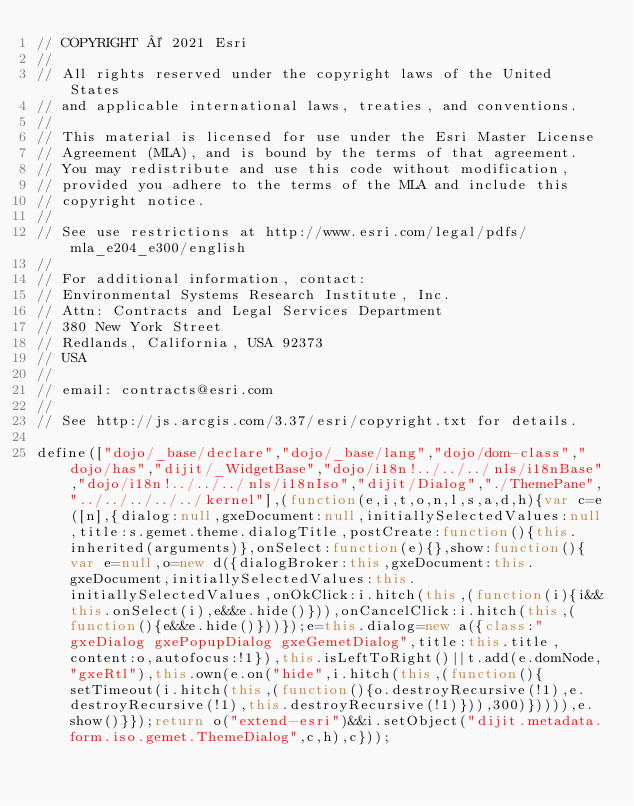<code> <loc_0><loc_0><loc_500><loc_500><_JavaScript_>// COPYRIGHT © 2021 Esri
//
// All rights reserved under the copyright laws of the United States
// and applicable international laws, treaties, and conventions.
//
// This material is licensed for use under the Esri Master License
// Agreement (MLA), and is bound by the terms of that agreement.
// You may redistribute and use this code without modification,
// provided you adhere to the terms of the MLA and include this
// copyright notice.
//
// See use restrictions at http://www.esri.com/legal/pdfs/mla_e204_e300/english
//
// For additional information, contact:
// Environmental Systems Research Institute, Inc.
// Attn: Contracts and Legal Services Department
// 380 New York Street
// Redlands, California, USA 92373
// USA
//
// email: contracts@esri.com
//
// See http://js.arcgis.com/3.37/esri/copyright.txt for details.

define(["dojo/_base/declare","dojo/_base/lang","dojo/dom-class","dojo/has","dijit/_WidgetBase","dojo/i18n!../../../nls/i18nBase","dojo/i18n!../../../nls/i18nIso","dijit/Dialog","./ThemePane","../../../../../kernel"],(function(e,i,t,o,n,l,s,a,d,h){var c=e([n],{dialog:null,gxeDocument:null,initiallySelectedValues:null,title:s.gemet.theme.dialogTitle,postCreate:function(){this.inherited(arguments)},onSelect:function(e){},show:function(){var e=null,o=new d({dialogBroker:this,gxeDocument:this.gxeDocument,initiallySelectedValues:this.initiallySelectedValues,onOkClick:i.hitch(this,(function(i){i&&this.onSelect(i),e&&e.hide()})),onCancelClick:i.hitch(this,(function(){e&&e.hide()}))});e=this.dialog=new a({class:"gxeDialog gxePopupDialog gxeGemetDialog",title:this.title,content:o,autofocus:!1}),this.isLeftToRight()||t.add(e.domNode,"gxeRtl"),this.own(e.on("hide",i.hitch(this,(function(){setTimeout(i.hitch(this,(function(){o.destroyRecursive(!1),e.destroyRecursive(!1),this.destroyRecursive(!1)})),300)})))),e.show()}});return o("extend-esri")&&i.setObject("dijit.metadata.form.iso.gemet.ThemeDialog",c,h),c}));</code> 